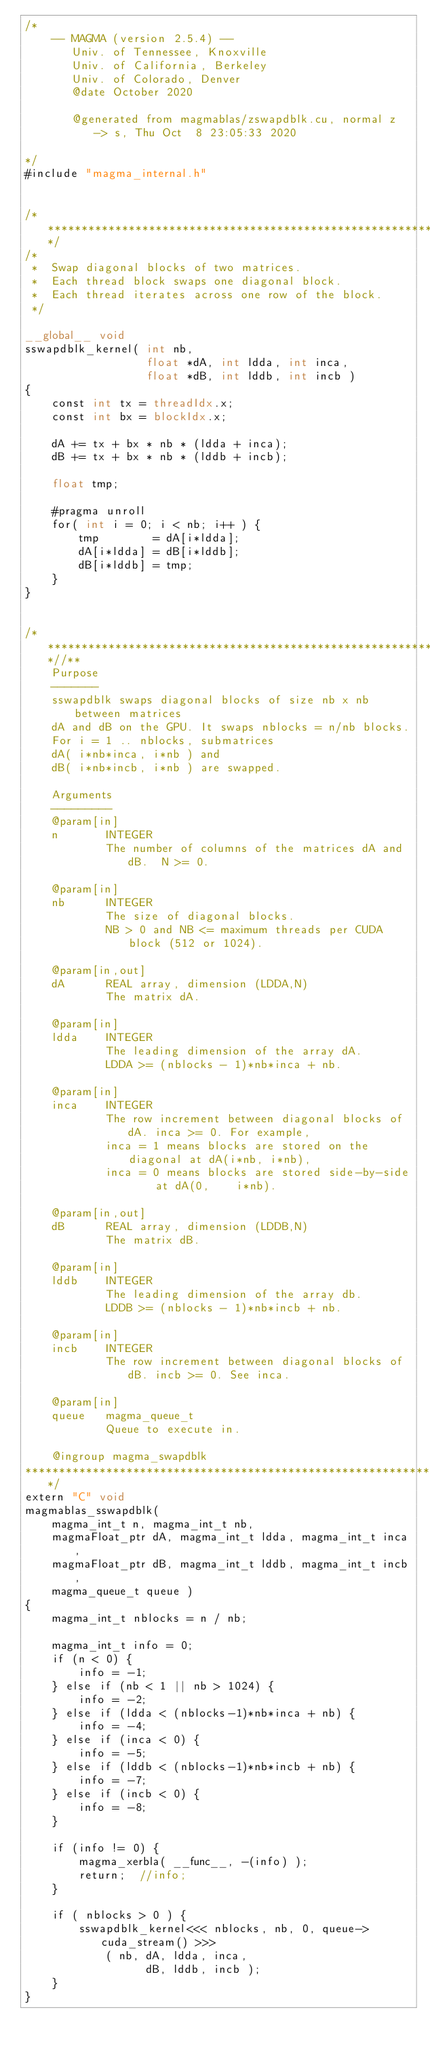<code> <loc_0><loc_0><loc_500><loc_500><_Cuda_>/*
    -- MAGMA (version 2.5.4) --
       Univ. of Tennessee, Knoxville
       Univ. of California, Berkeley
       Univ. of Colorado, Denver
       @date October 2020

       @generated from magmablas/zswapdblk.cu, normal z -> s, Thu Oct  8 23:05:33 2020

*/
#include "magma_internal.h"


/******************************************************************************/
/*
 *  Swap diagonal blocks of two matrices.
 *  Each thread block swaps one diagonal block.
 *  Each thread iterates across one row of the block.
 */

__global__ void 
sswapdblk_kernel( int nb,
                  float *dA, int ldda, int inca,
                  float *dB, int lddb, int incb )
{
    const int tx = threadIdx.x;
    const int bx = blockIdx.x;

    dA += tx + bx * nb * (ldda + inca);
    dB += tx + bx * nb * (lddb + incb);

    float tmp;

    #pragma unroll
    for( int i = 0; i < nb; i++ ) {
        tmp        = dA[i*ldda];
        dA[i*ldda] = dB[i*lddb];
        dB[i*lddb] = tmp;
    }
}


/***************************************************************************//**
    Purpose
    -------
    sswapdblk swaps diagonal blocks of size nb x nb between matrices
    dA and dB on the GPU. It swaps nblocks = n/nb blocks.
    For i = 1 .. nblocks, submatrices
    dA( i*nb*inca, i*nb ) and
    dB( i*nb*incb, i*nb ) are swapped.
    
    Arguments
    ---------
    @param[in]
    n       INTEGER
            The number of columns of the matrices dA and dB.  N >= 0.

    @param[in]
    nb      INTEGER
            The size of diagonal blocks.
            NB > 0 and NB <= maximum threads per CUDA block (512 or 1024).

    @param[in,out]
    dA      REAL array, dimension (LDDA,N)
            The matrix dA.

    @param[in]
    ldda    INTEGER
            The leading dimension of the array dA.
            LDDA >= (nblocks - 1)*nb*inca + nb.

    @param[in]
    inca    INTEGER
            The row increment between diagonal blocks of dA. inca >= 0. For example,
            inca = 1 means blocks are stored on the diagonal at dA(i*nb, i*nb),
            inca = 0 means blocks are stored side-by-side    at dA(0,    i*nb).

    @param[in,out]
    dB      REAL array, dimension (LDDB,N)
            The matrix dB.

    @param[in]
    lddb    INTEGER
            The leading dimension of the array db.
            LDDB >= (nblocks - 1)*nb*incb + nb.

    @param[in]
    incb    INTEGER
            The row increment between diagonal blocks of dB. incb >= 0. See inca.
    
    @param[in]
    queue   magma_queue_t
            Queue to execute in.

    @ingroup magma_swapdblk
*******************************************************************************/
extern "C" void 
magmablas_sswapdblk(
    magma_int_t n, magma_int_t nb,
    magmaFloat_ptr dA, magma_int_t ldda, magma_int_t inca,
    magmaFloat_ptr dB, magma_int_t lddb, magma_int_t incb,
    magma_queue_t queue )
{
    magma_int_t nblocks = n / nb;
    
    magma_int_t info = 0;
    if (n < 0) {
        info = -1;
    } else if (nb < 1 || nb > 1024) {
        info = -2;
    } else if (ldda < (nblocks-1)*nb*inca + nb) {
        info = -4;
    } else if (inca < 0) {
        info = -5;
    } else if (lddb < (nblocks-1)*nb*incb + nb) {
        info = -7;
    } else if (incb < 0) {
        info = -8;
    }

    if (info != 0) {
        magma_xerbla( __func__, -(info) );
        return;  //info;
    }

    if ( nblocks > 0 ) {
        sswapdblk_kernel<<< nblocks, nb, 0, queue->cuda_stream() >>>
            ( nb, dA, ldda, inca,
                  dB, lddb, incb );
    }
}
</code> 